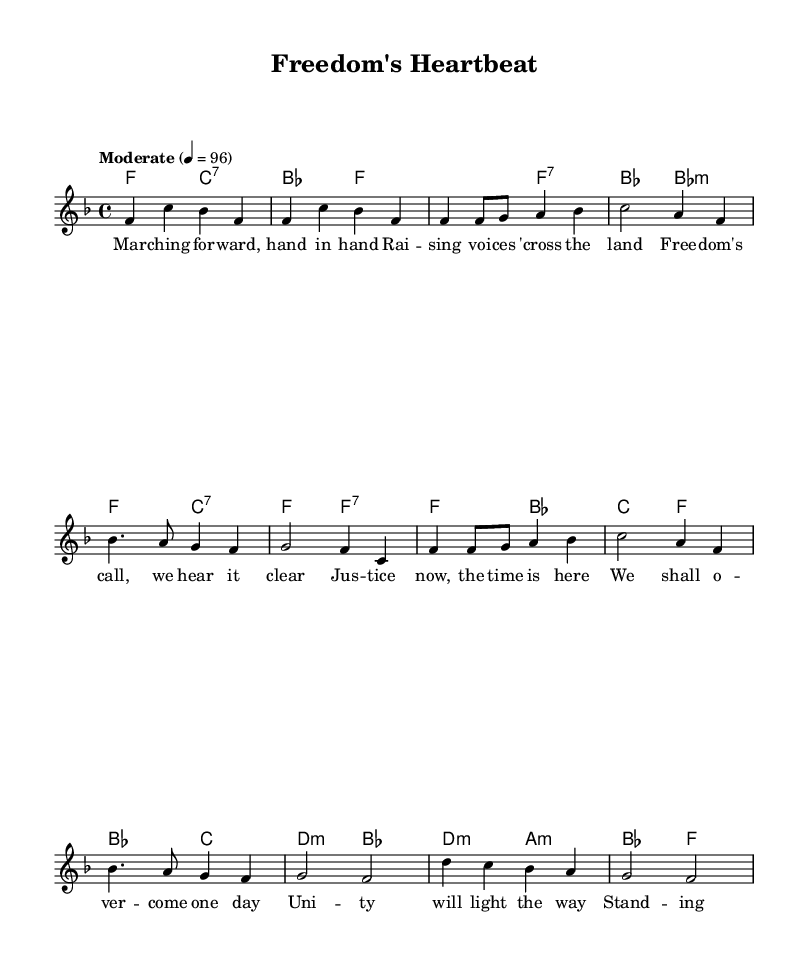What is the key signature of this music? The key signature is identified by the presence of one flat, indicating F major.
Answer: F major What is the time signature of this music? The time signature appears as a fraction at the beginning of the sheet music and shows 4 beats per measure, indicating common time.
Answer: 4/4 What is the tempo marking for this piece? The tempo marking indicates a speed of 96 beats per minute and indicates a "Moderate" pace.
Answer: Moderate How many measures are there in the verse section? To determine this, count the measures in the verse section, which consists of 4 phrases, traditionally framed in 4 measures each within standard song structure.
Answer: 4 measures What is the primary theme reflected in the lyrics? Reading through the lyric phrases emphasizes themes of unity and justice, correlating with social movements.
Answer: Unity In the chorus, how many lines of lyrics are there? By examining the structure of the chorus, count the number of written lines, which are typically organized consistently across the section.
Answer: 4 lines What chord type is used in the bridge section? The bridge section features minor chords, notably appearing as marked in the harmonies section, indicating a somber mood contrasted with the major themes.
Answer: Minor 